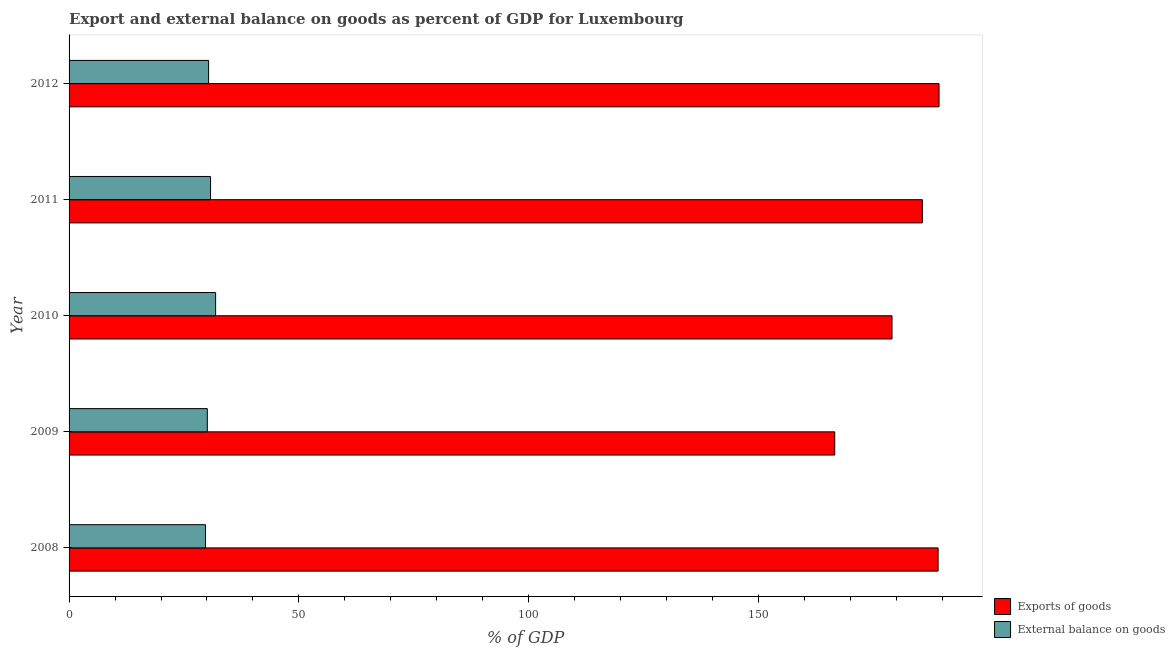How many different coloured bars are there?
Keep it short and to the point. 2. Are the number of bars on each tick of the Y-axis equal?
Keep it short and to the point. Yes. How many bars are there on the 3rd tick from the top?
Your answer should be compact. 2. What is the label of the 4th group of bars from the top?
Your answer should be very brief. 2009. What is the export of goods as percentage of gdp in 2008?
Make the answer very short. 189.04. Across all years, what is the maximum export of goods as percentage of gdp?
Your answer should be compact. 189.24. Across all years, what is the minimum external balance on goods as percentage of gdp?
Your response must be concise. 29.68. In which year was the external balance on goods as percentage of gdp maximum?
Provide a short and direct response. 2010. What is the total export of goods as percentage of gdp in the graph?
Give a very brief answer. 909.44. What is the difference between the external balance on goods as percentage of gdp in 2008 and that in 2011?
Provide a succinct answer. -1.09. What is the difference between the export of goods as percentage of gdp in 2009 and the external balance on goods as percentage of gdp in 2010?
Give a very brief answer. 134.67. What is the average export of goods as percentage of gdp per year?
Your response must be concise. 181.89. In the year 2012, what is the difference between the export of goods as percentage of gdp and external balance on goods as percentage of gdp?
Offer a very short reply. 158.88. In how many years, is the export of goods as percentage of gdp greater than 180 %?
Provide a succinct answer. 3. Is the difference between the external balance on goods as percentage of gdp in 2010 and 2012 greater than the difference between the export of goods as percentage of gdp in 2010 and 2012?
Provide a succinct answer. Yes. What is the difference between the highest and the second highest external balance on goods as percentage of gdp?
Provide a short and direct response. 1.11. What does the 1st bar from the top in 2011 represents?
Provide a succinct answer. External balance on goods. What does the 2nd bar from the bottom in 2012 represents?
Make the answer very short. External balance on goods. How many bars are there?
Provide a short and direct response. 10. What is the difference between two consecutive major ticks on the X-axis?
Your answer should be very brief. 50. Are the values on the major ticks of X-axis written in scientific E-notation?
Ensure brevity in your answer.  No. Does the graph contain grids?
Make the answer very short. No. What is the title of the graph?
Make the answer very short. Export and external balance on goods as percent of GDP for Luxembourg. What is the label or title of the X-axis?
Make the answer very short. % of GDP. What is the label or title of the Y-axis?
Offer a terse response. Year. What is the % of GDP in Exports of goods in 2008?
Keep it short and to the point. 189.04. What is the % of GDP in External balance on goods in 2008?
Provide a short and direct response. 29.68. What is the % of GDP in Exports of goods in 2009?
Keep it short and to the point. 166.55. What is the % of GDP of External balance on goods in 2009?
Provide a succinct answer. 30.07. What is the % of GDP in Exports of goods in 2010?
Your answer should be very brief. 179.01. What is the % of GDP of External balance on goods in 2010?
Offer a terse response. 31.88. What is the % of GDP of Exports of goods in 2011?
Make the answer very short. 185.61. What is the % of GDP of External balance on goods in 2011?
Make the answer very short. 30.77. What is the % of GDP of Exports of goods in 2012?
Your answer should be very brief. 189.24. What is the % of GDP of External balance on goods in 2012?
Make the answer very short. 30.35. Across all years, what is the maximum % of GDP of Exports of goods?
Your response must be concise. 189.24. Across all years, what is the maximum % of GDP in External balance on goods?
Ensure brevity in your answer.  31.88. Across all years, what is the minimum % of GDP of Exports of goods?
Your answer should be compact. 166.55. Across all years, what is the minimum % of GDP in External balance on goods?
Give a very brief answer. 29.68. What is the total % of GDP in Exports of goods in the graph?
Your answer should be very brief. 909.44. What is the total % of GDP of External balance on goods in the graph?
Your answer should be very brief. 152.75. What is the difference between the % of GDP in Exports of goods in 2008 and that in 2009?
Make the answer very short. 22.49. What is the difference between the % of GDP of External balance on goods in 2008 and that in 2009?
Make the answer very short. -0.39. What is the difference between the % of GDP in Exports of goods in 2008 and that in 2010?
Your answer should be compact. 10.03. What is the difference between the % of GDP of External balance on goods in 2008 and that in 2010?
Ensure brevity in your answer.  -2.2. What is the difference between the % of GDP of Exports of goods in 2008 and that in 2011?
Make the answer very short. 3.43. What is the difference between the % of GDP of External balance on goods in 2008 and that in 2011?
Make the answer very short. -1.09. What is the difference between the % of GDP in Exports of goods in 2008 and that in 2012?
Make the answer very short. -0.2. What is the difference between the % of GDP of External balance on goods in 2008 and that in 2012?
Your answer should be very brief. -0.67. What is the difference between the % of GDP in Exports of goods in 2009 and that in 2010?
Give a very brief answer. -12.46. What is the difference between the % of GDP in External balance on goods in 2009 and that in 2010?
Ensure brevity in your answer.  -1.81. What is the difference between the % of GDP of Exports of goods in 2009 and that in 2011?
Your response must be concise. -19.06. What is the difference between the % of GDP of External balance on goods in 2009 and that in 2011?
Make the answer very short. -0.7. What is the difference between the % of GDP of Exports of goods in 2009 and that in 2012?
Your answer should be compact. -22.69. What is the difference between the % of GDP of External balance on goods in 2009 and that in 2012?
Your answer should be compact. -0.28. What is the difference between the % of GDP in Exports of goods in 2010 and that in 2011?
Your answer should be very brief. -6.6. What is the difference between the % of GDP in External balance on goods in 2010 and that in 2011?
Your answer should be very brief. 1.11. What is the difference between the % of GDP in Exports of goods in 2010 and that in 2012?
Give a very brief answer. -10.23. What is the difference between the % of GDP of External balance on goods in 2010 and that in 2012?
Provide a short and direct response. 1.53. What is the difference between the % of GDP in Exports of goods in 2011 and that in 2012?
Provide a succinct answer. -3.63. What is the difference between the % of GDP in External balance on goods in 2011 and that in 2012?
Your answer should be very brief. 0.42. What is the difference between the % of GDP in Exports of goods in 2008 and the % of GDP in External balance on goods in 2009?
Keep it short and to the point. 158.97. What is the difference between the % of GDP of Exports of goods in 2008 and the % of GDP of External balance on goods in 2010?
Your answer should be compact. 157.16. What is the difference between the % of GDP of Exports of goods in 2008 and the % of GDP of External balance on goods in 2011?
Your response must be concise. 158.26. What is the difference between the % of GDP in Exports of goods in 2008 and the % of GDP in External balance on goods in 2012?
Your response must be concise. 158.68. What is the difference between the % of GDP in Exports of goods in 2009 and the % of GDP in External balance on goods in 2010?
Make the answer very short. 134.67. What is the difference between the % of GDP of Exports of goods in 2009 and the % of GDP of External balance on goods in 2011?
Your response must be concise. 135.77. What is the difference between the % of GDP in Exports of goods in 2009 and the % of GDP in External balance on goods in 2012?
Offer a very short reply. 136.19. What is the difference between the % of GDP in Exports of goods in 2010 and the % of GDP in External balance on goods in 2011?
Your response must be concise. 148.24. What is the difference between the % of GDP in Exports of goods in 2010 and the % of GDP in External balance on goods in 2012?
Keep it short and to the point. 148.66. What is the difference between the % of GDP in Exports of goods in 2011 and the % of GDP in External balance on goods in 2012?
Offer a terse response. 155.26. What is the average % of GDP in Exports of goods per year?
Your answer should be very brief. 181.89. What is the average % of GDP of External balance on goods per year?
Provide a short and direct response. 30.55. In the year 2008, what is the difference between the % of GDP of Exports of goods and % of GDP of External balance on goods?
Your answer should be compact. 159.36. In the year 2009, what is the difference between the % of GDP of Exports of goods and % of GDP of External balance on goods?
Provide a succinct answer. 136.48. In the year 2010, what is the difference between the % of GDP in Exports of goods and % of GDP in External balance on goods?
Offer a very short reply. 147.13. In the year 2011, what is the difference between the % of GDP in Exports of goods and % of GDP in External balance on goods?
Provide a short and direct response. 154.84. In the year 2012, what is the difference between the % of GDP of Exports of goods and % of GDP of External balance on goods?
Provide a succinct answer. 158.88. What is the ratio of the % of GDP of Exports of goods in 2008 to that in 2009?
Provide a succinct answer. 1.14. What is the ratio of the % of GDP in Exports of goods in 2008 to that in 2010?
Keep it short and to the point. 1.06. What is the ratio of the % of GDP of Exports of goods in 2008 to that in 2011?
Your answer should be compact. 1.02. What is the ratio of the % of GDP of External balance on goods in 2008 to that in 2011?
Keep it short and to the point. 0.96. What is the ratio of the % of GDP of Exports of goods in 2008 to that in 2012?
Provide a short and direct response. 1. What is the ratio of the % of GDP of External balance on goods in 2008 to that in 2012?
Your response must be concise. 0.98. What is the ratio of the % of GDP in Exports of goods in 2009 to that in 2010?
Offer a very short reply. 0.93. What is the ratio of the % of GDP in External balance on goods in 2009 to that in 2010?
Offer a terse response. 0.94. What is the ratio of the % of GDP of Exports of goods in 2009 to that in 2011?
Your response must be concise. 0.9. What is the ratio of the % of GDP in External balance on goods in 2009 to that in 2011?
Provide a short and direct response. 0.98. What is the ratio of the % of GDP in Exports of goods in 2009 to that in 2012?
Your response must be concise. 0.88. What is the ratio of the % of GDP in Exports of goods in 2010 to that in 2011?
Offer a terse response. 0.96. What is the ratio of the % of GDP of External balance on goods in 2010 to that in 2011?
Offer a very short reply. 1.04. What is the ratio of the % of GDP in Exports of goods in 2010 to that in 2012?
Your answer should be very brief. 0.95. What is the ratio of the % of GDP of External balance on goods in 2010 to that in 2012?
Offer a very short reply. 1.05. What is the ratio of the % of GDP in Exports of goods in 2011 to that in 2012?
Offer a terse response. 0.98. What is the ratio of the % of GDP of External balance on goods in 2011 to that in 2012?
Ensure brevity in your answer.  1.01. What is the difference between the highest and the second highest % of GDP in Exports of goods?
Your response must be concise. 0.2. What is the difference between the highest and the second highest % of GDP of External balance on goods?
Offer a very short reply. 1.11. What is the difference between the highest and the lowest % of GDP in Exports of goods?
Make the answer very short. 22.69. What is the difference between the highest and the lowest % of GDP in External balance on goods?
Offer a very short reply. 2.2. 